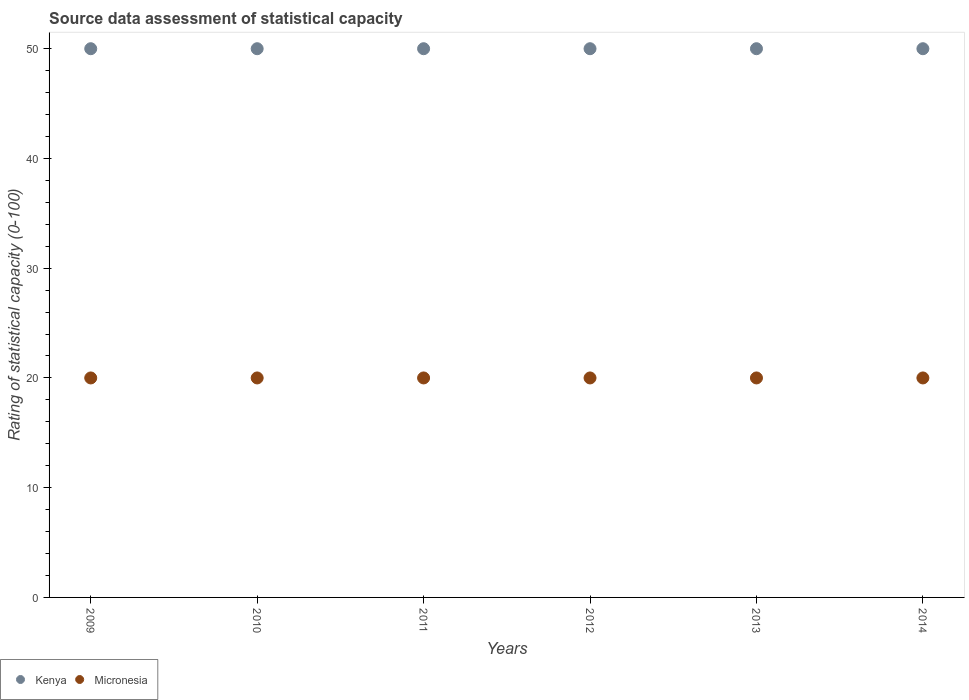How many different coloured dotlines are there?
Offer a terse response. 2. Is the number of dotlines equal to the number of legend labels?
Provide a succinct answer. Yes. Across all years, what is the maximum rating of statistical capacity in Micronesia?
Keep it short and to the point. 20. Across all years, what is the minimum rating of statistical capacity in Kenya?
Your response must be concise. 50. In which year was the rating of statistical capacity in Kenya maximum?
Your response must be concise. 2009. What is the total rating of statistical capacity in Kenya in the graph?
Make the answer very short. 300. What is the difference between the rating of statistical capacity in Micronesia in 2009 and that in 2012?
Your response must be concise. 0. What is the difference between the rating of statistical capacity in Kenya in 2011 and the rating of statistical capacity in Micronesia in 2010?
Give a very brief answer. 30. What is the average rating of statistical capacity in Micronesia per year?
Ensure brevity in your answer.  20. In the year 2011, what is the difference between the rating of statistical capacity in Micronesia and rating of statistical capacity in Kenya?
Your answer should be very brief. -30. What is the ratio of the rating of statistical capacity in Micronesia in 2013 to that in 2014?
Offer a terse response. 1. What is the difference between the highest and the second highest rating of statistical capacity in Micronesia?
Make the answer very short. 0. What is the difference between the highest and the lowest rating of statistical capacity in Kenya?
Offer a very short reply. 0. Does the rating of statistical capacity in Micronesia monotonically increase over the years?
Offer a terse response. No. Is the rating of statistical capacity in Kenya strictly less than the rating of statistical capacity in Micronesia over the years?
Ensure brevity in your answer.  No. How many years are there in the graph?
Your answer should be compact. 6. Are the values on the major ticks of Y-axis written in scientific E-notation?
Offer a terse response. No. Where does the legend appear in the graph?
Ensure brevity in your answer.  Bottom left. How many legend labels are there?
Provide a succinct answer. 2. How are the legend labels stacked?
Offer a terse response. Horizontal. What is the title of the graph?
Provide a succinct answer. Source data assessment of statistical capacity. What is the label or title of the X-axis?
Your response must be concise. Years. What is the label or title of the Y-axis?
Your response must be concise. Rating of statistical capacity (0-100). What is the Rating of statistical capacity (0-100) in Kenya in 2010?
Your response must be concise. 50. What is the Rating of statistical capacity (0-100) in Micronesia in 2010?
Offer a very short reply. 20. What is the Rating of statistical capacity (0-100) in Micronesia in 2012?
Your answer should be compact. 20. What is the Rating of statistical capacity (0-100) in Kenya in 2013?
Offer a very short reply. 50. What is the Rating of statistical capacity (0-100) in Kenya in 2014?
Keep it short and to the point. 50. What is the Rating of statistical capacity (0-100) in Micronesia in 2014?
Give a very brief answer. 20. Across all years, what is the maximum Rating of statistical capacity (0-100) of Micronesia?
Offer a terse response. 20. What is the total Rating of statistical capacity (0-100) in Kenya in the graph?
Provide a short and direct response. 300. What is the total Rating of statistical capacity (0-100) of Micronesia in the graph?
Offer a very short reply. 120. What is the difference between the Rating of statistical capacity (0-100) in Kenya in 2009 and that in 2010?
Your answer should be compact. 0. What is the difference between the Rating of statistical capacity (0-100) of Micronesia in 2009 and that in 2010?
Provide a short and direct response. 0. What is the difference between the Rating of statistical capacity (0-100) in Kenya in 2009 and that in 2011?
Keep it short and to the point. 0. What is the difference between the Rating of statistical capacity (0-100) in Kenya in 2009 and that in 2012?
Your answer should be compact. 0. What is the difference between the Rating of statistical capacity (0-100) in Micronesia in 2009 and that in 2012?
Give a very brief answer. 0. What is the difference between the Rating of statistical capacity (0-100) in Kenya in 2009 and that in 2014?
Provide a succinct answer. 0. What is the difference between the Rating of statistical capacity (0-100) of Micronesia in 2009 and that in 2014?
Offer a very short reply. 0. What is the difference between the Rating of statistical capacity (0-100) in Kenya in 2010 and that in 2011?
Make the answer very short. 0. What is the difference between the Rating of statistical capacity (0-100) of Micronesia in 2010 and that in 2011?
Provide a short and direct response. 0. What is the difference between the Rating of statistical capacity (0-100) in Kenya in 2010 and that in 2012?
Your response must be concise. 0. What is the difference between the Rating of statistical capacity (0-100) in Kenya in 2010 and that in 2013?
Give a very brief answer. 0. What is the difference between the Rating of statistical capacity (0-100) in Micronesia in 2010 and that in 2013?
Offer a terse response. 0. What is the difference between the Rating of statistical capacity (0-100) of Kenya in 2010 and that in 2014?
Your answer should be compact. 0. What is the difference between the Rating of statistical capacity (0-100) of Micronesia in 2011 and that in 2013?
Offer a terse response. 0. What is the difference between the Rating of statistical capacity (0-100) in Kenya in 2012 and that in 2013?
Keep it short and to the point. 0. What is the difference between the Rating of statistical capacity (0-100) in Kenya in 2012 and that in 2014?
Your response must be concise. 0. What is the difference between the Rating of statistical capacity (0-100) in Kenya in 2013 and that in 2014?
Offer a terse response. 0. What is the difference between the Rating of statistical capacity (0-100) of Micronesia in 2013 and that in 2014?
Your answer should be very brief. 0. What is the difference between the Rating of statistical capacity (0-100) of Kenya in 2009 and the Rating of statistical capacity (0-100) of Micronesia in 2010?
Your response must be concise. 30. What is the difference between the Rating of statistical capacity (0-100) of Kenya in 2009 and the Rating of statistical capacity (0-100) of Micronesia in 2012?
Give a very brief answer. 30. What is the difference between the Rating of statistical capacity (0-100) of Kenya in 2009 and the Rating of statistical capacity (0-100) of Micronesia in 2013?
Ensure brevity in your answer.  30. What is the difference between the Rating of statistical capacity (0-100) in Kenya in 2010 and the Rating of statistical capacity (0-100) in Micronesia in 2011?
Offer a terse response. 30. What is the difference between the Rating of statistical capacity (0-100) of Kenya in 2011 and the Rating of statistical capacity (0-100) of Micronesia in 2012?
Provide a short and direct response. 30. What is the difference between the Rating of statistical capacity (0-100) in Kenya in 2011 and the Rating of statistical capacity (0-100) in Micronesia in 2014?
Provide a succinct answer. 30. In the year 2009, what is the difference between the Rating of statistical capacity (0-100) of Kenya and Rating of statistical capacity (0-100) of Micronesia?
Keep it short and to the point. 30. In the year 2011, what is the difference between the Rating of statistical capacity (0-100) of Kenya and Rating of statistical capacity (0-100) of Micronesia?
Keep it short and to the point. 30. In the year 2012, what is the difference between the Rating of statistical capacity (0-100) of Kenya and Rating of statistical capacity (0-100) of Micronesia?
Offer a terse response. 30. In the year 2013, what is the difference between the Rating of statistical capacity (0-100) in Kenya and Rating of statistical capacity (0-100) in Micronesia?
Provide a short and direct response. 30. In the year 2014, what is the difference between the Rating of statistical capacity (0-100) in Kenya and Rating of statistical capacity (0-100) in Micronesia?
Ensure brevity in your answer.  30. What is the ratio of the Rating of statistical capacity (0-100) of Kenya in 2009 to that in 2012?
Offer a terse response. 1. What is the ratio of the Rating of statistical capacity (0-100) of Kenya in 2009 to that in 2014?
Ensure brevity in your answer.  1. What is the ratio of the Rating of statistical capacity (0-100) in Micronesia in 2010 to that in 2011?
Ensure brevity in your answer.  1. What is the ratio of the Rating of statistical capacity (0-100) in Micronesia in 2010 to that in 2013?
Offer a very short reply. 1. What is the ratio of the Rating of statistical capacity (0-100) of Micronesia in 2010 to that in 2014?
Your answer should be very brief. 1. What is the ratio of the Rating of statistical capacity (0-100) in Kenya in 2012 to that in 2013?
Your answer should be very brief. 1. What is the ratio of the Rating of statistical capacity (0-100) of Kenya in 2012 to that in 2014?
Offer a terse response. 1. What is the ratio of the Rating of statistical capacity (0-100) of Micronesia in 2013 to that in 2014?
Give a very brief answer. 1. What is the difference between the highest and the second highest Rating of statistical capacity (0-100) in Kenya?
Provide a succinct answer. 0. What is the difference between the highest and the second highest Rating of statistical capacity (0-100) in Micronesia?
Your answer should be compact. 0. 